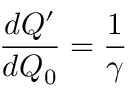Convert formula to latex. <formula><loc_0><loc_0><loc_500><loc_500>\frac { d Q ^ { \prime } } { d Q _ { 0 } } = \frac { 1 } { \gamma }</formula> 